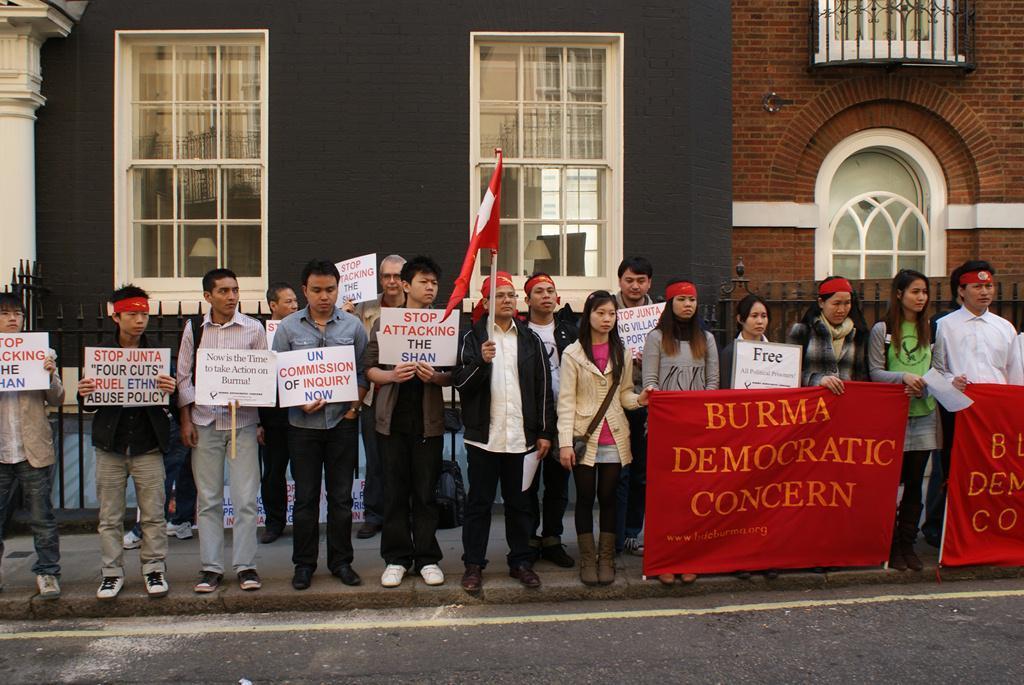Describe this image in one or two sentences. In this image I can see number of people are standing. I can see most of them are holding boards and few of them are holding red colour banners. I can also see one person is holding a flag. On these boards and on these banners I can see something is written. In the background I can see buildings and windows. 